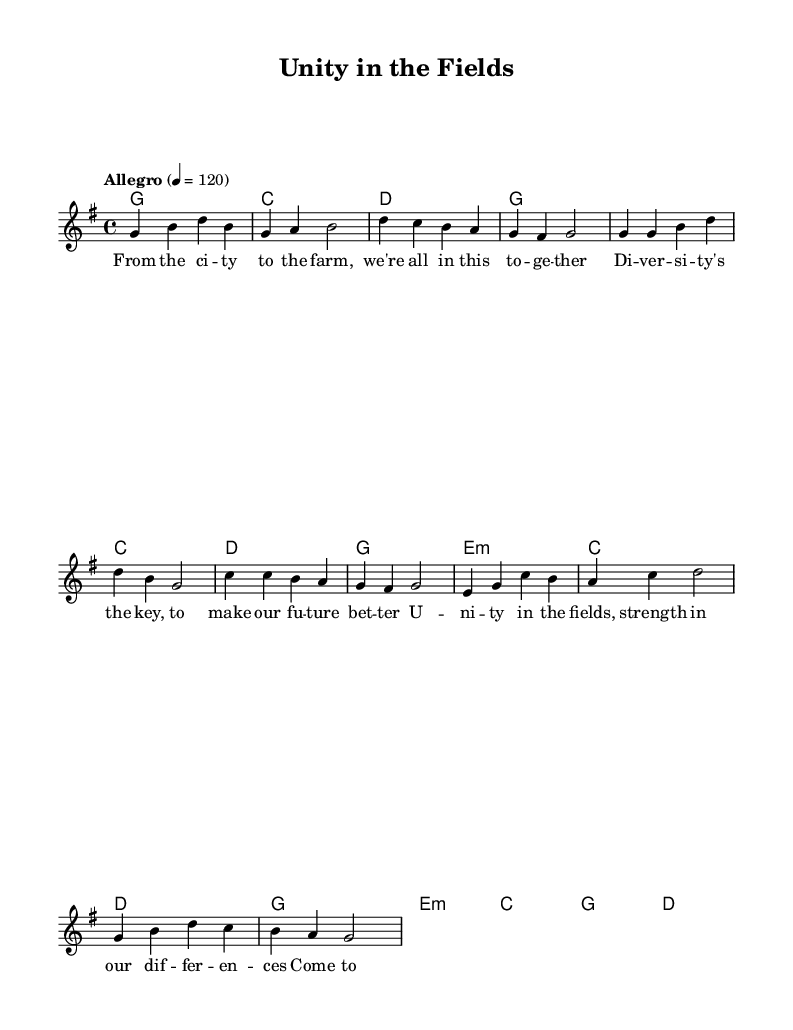What is the key signature of this music? The key signature is G major, which has one sharp (F#).
Answer: G major What is the time signature of this music? The time signature is 4/4, indicating four beats per measure.
Answer: 4/4 What is the tempo marking for this piece? The tempo marking is "Allegro," which suggests a quick and lively pace.
Answer: Allegro How many measures are in the Verse section? The Verse section consists of four measures, as represented by the grouping of notes.
Answer: Four What is the last chord in the bridge section? The last chord in the bridge section is D major, as indicated at the end of the harmonic progression.
Answer: D What is the main theme of the lyrics in this piece? The main theme of the lyrics emphasizes unity and the importance of diversity in business and agriculture.
Answer: Unity and diversity How does the chorus structure relate to the verse structure? The chorus structure follows a similar format to the verse, maintaining a rhythmic and melodic continuity, reinforcing the themes of the song.
Answer: Similar format and continuity 